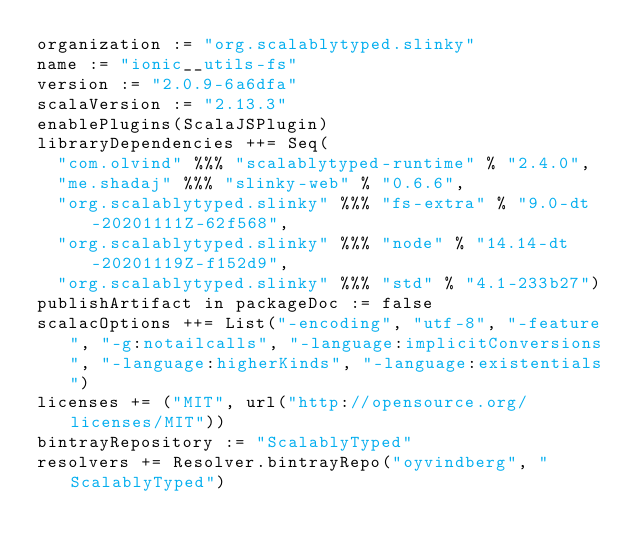<code> <loc_0><loc_0><loc_500><loc_500><_Scala_>organization := "org.scalablytyped.slinky"
name := "ionic__utils-fs"
version := "2.0.9-6a6dfa"
scalaVersion := "2.13.3"
enablePlugins(ScalaJSPlugin)
libraryDependencies ++= Seq(
  "com.olvind" %%% "scalablytyped-runtime" % "2.4.0",
  "me.shadaj" %%% "slinky-web" % "0.6.6",
  "org.scalablytyped.slinky" %%% "fs-extra" % "9.0-dt-20201111Z-62f568",
  "org.scalablytyped.slinky" %%% "node" % "14.14-dt-20201119Z-f152d9",
  "org.scalablytyped.slinky" %%% "std" % "4.1-233b27")
publishArtifact in packageDoc := false
scalacOptions ++= List("-encoding", "utf-8", "-feature", "-g:notailcalls", "-language:implicitConversions", "-language:higherKinds", "-language:existentials")
licenses += ("MIT", url("http://opensource.org/licenses/MIT"))
bintrayRepository := "ScalablyTyped"
resolvers += Resolver.bintrayRepo("oyvindberg", "ScalablyTyped")
</code> 